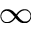Convert formula to latex. <formula><loc_0><loc_0><loc_500><loc_500>_ { \infty }</formula> 